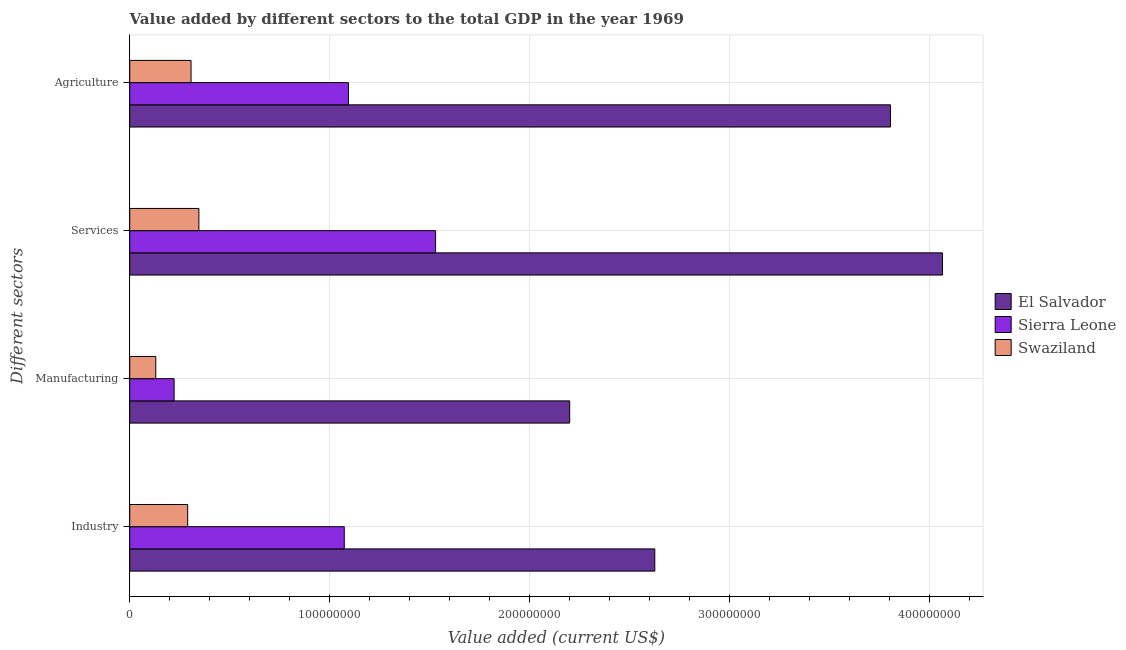How many different coloured bars are there?
Offer a terse response. 3. Are the number of bars per tick equal to the number of legend labels?
Provide a succinct answer. Yes. Are the number of bars on each tick of the Y-axis equal?
Provide a succinct answer. Yes. How many bars are there on the 2nd tick from the bottom?
Make the answer very short. 3. What is the label of the 4th group of bars from the top?
Keep it short and to the point. Industry. What is the value added by agricultural sector in Swaziland?
Make the answer very short. 3.07e+07. Across all countries, what is the maximum value added by industrial sector?
Give a very brief answer. 2.63e+08. Across all countries, what is the minimum value added by manufacturing sector?
Your answer should be very brief. 1.30e+07. In which country was the value added by manufacturing sector maximum?
Your answer should be very brief. El Salvador. In which country was the value added by agricultural sector minimum?
Offer a very short reply. Swaziland. What is the total value added by services sector in the graph?
Keep it short and to the point. 5.94e+08. What is the difference between the value added by manufacturing sector in Swaziland and that in Sierra Leone?
Your response must be concise. -9.18e+06. What is the difference between the value added by industrial sector in Swaziland and the value added by manufacturing sector in Sierra Leone?
Make the answer very short. 6.78e+06. What is the average value added by services sector per country?
Your answer should be compact. 1.98e+08. What is the difference between the value added by agricultural sector and value added by manufacturing sector in El Salvador?
Your response must be concise. 1.60e+08. In how many countries, is the value added by industrial sector greater than 40000000 US$?
Provide a short and direct response. 2. What is the ratio of the value added by industrial sector in El Salvador to that in Sierra Leone?
Provide a short and direct response. 2.45. What is the difference between the highest and the second highest value added by manufacturing sector?
Your response must be concise. 1.98e+08. What is the difference between the highest and the lowest value added by services sector?
Your answer should be very brief. 3.72e+08. What does the 2nd bar from the top in Agriculture represents?
Offer a very short reply. Sierra Leone. What does the 2nd bar from the bottom in Agriculture represents?
Your response must be concise. Sierra Leone. Is it the case that in every country, the sum of the value added by industrial sector and value added by manufacturing sector is greater than the value added by services sector?
Keep it short and to the point. No. How many bars are there?
Provide a succinct answer. 12. Are all the bars in the graph horizontal?
Offer a terse response. Yes. Are the values on the major ticks of X-axis written in scientific E-notation?
Ensure brevity in your answer.  No. Does the graph contain any zero values?
Ensure brevity in your answer.  No. Does the graph contain grids?
Your response must be concise. Yes. How are the legend labels stacked?
Keep it short and to the point. Vertical. What is the title of the graph?
Give a very brief answer. Value added by different sectors to the total GDP in the year 1969. What is the label or title of the X-axis?
Offer a terse response. Value added (current US$). What is the label or title of the Y-axis?
Give a very brief answer. Different sectors. What is the Value added (current US$) of El Salvador in Industry?
Provide a succinct answer. 2.63e+08. What is the Value added (current US$) of Sierra Leone in Industry?
Provide a short and direct response. 1.07e+08. What is the Value added (current US$) in Swaziland in Industry?
Make the answer very short. 2.90e+07. What is the Value added (current US$) of El Salvador in Manufacturing?
Provide a succinct answer. 2.20e+08. What is the Value added (current US$) of Sierra Leone in Manufacturing?
Your answer should be very brief. 2.22e+07. What is the Value added (current US$) in Swaziland in Manufacturing?
Ensure brevity in your answer.  1.30e+07. What is the Value added (current US$) of El Salvador in Services?
Ensure brevity in your answer.  4.06e+08. What is the Value added (current US$) of Sierra Leone in Services?
Your answer should be compact. 1.53e+08. What is the Value added (current US$) in Swaziland in Services?
Your response must be concise. 3.46e+07. What is the Value added (current US$) in El Salvador in Agriculture?
Offer a very short reply. 3.80e+08. What is the Value added (current US$) in Sierra Leone in Agriculture?
Provide a succinct answer. 1.09e+08. What is the Value added (current US$) of Swaziland in Agriculture?
Your answer should be compact. 3.07e+07. Across all Different sectors, what is the maximum Value added (current US$) of El Salvador?
Ensure brevity in your answer.  4.06e+08. Across all Different sectors, what is the maximum Value added (current US$) of Sierra Leone?
Your response must be concise. 1.53e+08. Across all Different sectors, what is the maximum Value added (current US$) of Swaziland?
Keep it short and to the point. 3.46e+07. Across all Different sectors, what is the minimum Value added (current US$) in El Salvador?
Provide a succinct answer. 2.20e+08. Across all Different sectors, what is the minimum Value added (current US$) in Sierra Leone?
Make the answer very short. 2.22e+07. Across all Different sectors, what is the minimum Value added (current US$) in Swaziland?
Provide a short and direct response. 1.30e+07. What is the total Value added (current US$) in El Salvador in the graph?
Your answer should be very brief. 1.27e+09. What is the total Value added (current US$) of Sierra Leone in the graph?
Your response must be concise. 3.92e+08. What is the total Value added (current US$) in Swaziland in the graph?
Ensure brevity in your answer.  1.07e+08. What is the difference between the Value added (current US$) of El Salvador in Industry and that in Manufacturing?
Offer a terse response. 4.26e+07. What is the difference between the Value added (current US$) in Sierra Leone in Industry and that in Manufacturing?
Give a very brief answer. 8.51e+07. What is the difference between the Value added (current US$) in Swaziland in Industry and that in Manufacturing?
Give a very brief answer. 1.60e+07. What is the difference between the Value added (current US$) of El Salvador in Industry and that in Services?
Make the answer very short. -1.44e+08. What is the difference between the Value added (current US$) of Sierra Leone in Industry and that in Services?
Offer a very short reply. -4.57e+07. What is the difference between the Value added (current US$) in Swaziland in Industry and that in Services?
Your answer should be very brief. -5.60e+06. What is the difference between the Value added (current US$) in El Salvador in Industry and that in Agriculture?
Your answer should be very brief. -1.18e+08. What is the difference between the Value added (current US$) of Sierra Leone in Industry and that in Agriculture?
Your answer should be very brief. -2.10e+06. What is the difference between the Value added (current US$) in Swaziland in Industry and that in Agriculture?
Keep it short and to the point. -1.68e+06. What is the difference between the Value added (current US$) of El Salvador in Manufacturing and that in Services?
Give a very brief answer. -1.86e+08. What is the difference between the Value added (current US$) of Sierra Leone in Manufacturing and that in Services?
Offer a terse response. -1.31e+08. What is the difference between the Value added (current US$) in Swaziland in Manufacturing and that in Services?
Make the answer very short. -2.16e+07. What is the difference between the Value added (current US$) in El Salvador in Manufacturing and that in Agriculture?
Make the answer very short. -1.60e+08. What is the difference between the Value added (current US$) of Sierra Leone in Manufacturing and that in Agriculture?
Provide a succinct answer. -8.72e+07. What is the difference between the Value added (current US$) of Swaziland in Manufacturing and that in Agriculture?
Make the answer very short. -1.76e+07. What is the difference between the Value added (current US$) of El Salvador in Services and that in Agriculture?
Make the answer very short. 2.60e+07. What is the difference between the Value added (current US$) in Sierra Leone in Services and that in Agriculture?
Make the answer very short. 4.36e+07. What is the difference between the Value added (current US$) in Swaziland in Services and that in Agriculture?
Offer a terse response. 3.92e+06. What is the difference between the Value added (current US$) of El Salvador in Industry and the Value added (current US$) of Sierra Leone in Manufacturing?
Make the answer very short. 2.40e+08. What is the difference between the Value added (current US$) in El Salvador in Industry and the Value added (current US$) in Swaziland in Manufacturing?
Provide a short and direct response. 2.50e+08. What is the difference between the Value added (current US$) in Sierra Leone in Industry and the Value added (current US$) in Swaziland in Manufacturing?
Your response must be concise. 9.43e+07. What is the difference between the Value added (current US$) in El Salvador in Industry and the Value added (current US$) in Sierra Leone in Services?
Ensure brevity in your answer.  1.10e+08. What is the difference between the Value added (current US$) of El Salvador in Industry and the Value added (current US$) of Swaziland in Services?
Offer a terse response. 2.28e+08. What is the difference between the Value added (current US$) in Sierra Leone in Industry and the Value added (current US$) in Swaziland in Services?
Your response must be concise. 7.27e+07. What is the difference between the Value added (current US$) of El Salvador in Industry and the Value added (current US$) of Sierra Leone in Agriculture?
Make the answer very short. 1.53e+08. What is the difference between the Value added (current US$) in El Salvador in Industry and the Value added (current US$) in Swaziland in Agriculture?
Make the answer very short. 2.32e+08. What is the difference between the Value added (current US$) in Sierra Leone in Industry and the Value added (current US$) in Swaziland in Agriculture?
Offer a very short reply. 7.66e+07. What is the difference between the Value added (current US$) in El Salvador in Manufacturing and the Value added (current US$) in Sierra Leone in Services?
Your answer should be very brief. 6.71e+07. What is the difference between the Value added (current US$) of El Salvador in Manufacturing and the Value added (current US$) of Swaziland in Services?
Offer a very short reply. 1.85e+08. What is the difference between the Value added (current US$) of Sierra Leone in Manufacturing and the Value added (current US$) of Swaziland in Services?
Make the answer very short. -1.24e+07. What is the difference between the Value added (current US$) of El Salvador in Manufacturing and the Value added (current US$) of Sierra Leone in Agriculture?
Your answer should be compact. 1.11e+08. What is the difference between the Value added (current US$) in El Salvador in Manufacturing and the Value added (current US$) in Swaziland in Agriculture?
Your answer should be very brief. 1.89e+08. What is the difference between the Value added (current US$) in Sierra Leone in Manufacturing and the Value added (current US$) in Swaziland in Agriculture?
Provide a short and direct response. -8.46e+06. What is the difference between the Value added (current US$) of El Salvador in Services and the Value added (current US$) of Sierra Leone in Agriculture?
Keep it short and to the point. 2.97e+08. What is the difference between the Value added (current US$) of El Salvador in Services and the Value added (current US$) of Swaziland in Agriculture?
Make the answer very short. 3.76e+08. What is the difference between the Value added (current US$) of Sierra Leone in Services and the Value added (current US$) of Swaziland in Agriculture?
Provide a succinct answer. 1.22e+08. What is the average Value added (current US$) of El Salvador per Different sectors?
Your answer should be very brief. 3.17e+08. What is the average Value added (current US$) of Sierra Leone per Different sectors?
Your response must be concise. 9.80e+07. What is the average Value added (current US$) of Swaziland per Different sectors?
Make the answer very short. 2.68e+07. What is the difference between the Value added (current US$) of El Salvador and Value added (current US$) of Sierra Leone in Industry?
Make the answer very short. 1.55e+08. What is the difference between the Value added (current US$) of El Salvador and Value added (current US$) of Swaziland in Industry?
Keep it short and to the point. 2.34e+08. What is the difference between the Value added (current US$) in Sierra Leone and Value added (current US$) in Swaziland in Industry?
Offer a very short reply. 7.83e+07. What is the difference between the Value added (current US$) in El Salvador and Value added (current US$) in Sierra Leone in Manufacturing?
Offer a terse response. 1.98e+08. What is the difference between the Value added (current US$) in El Salvador and Value added (current US$) in Swaziland in Manufacturing?
Your response must be concise. 2.07e+08. What is the difference between the Value added (current US$) in Sierra Leone and Value added (current US$) in Swaziland in Manufacturing?
Offer a very short reply. 9.18e+06. What is the difference between the Value added (current US$) in El Salvador and Value added (current US$) in Sierra Leone in Services?
Your answer should be very brief. 2.53e+08. What is the difference between the Value added (current US$) of El Salvador and Value added (current US$) of Swaziland in Services?
Ensure brevity in your answer.  3.72e+08. What is the difference between the Value added (current US$) in Sierra Leone and Value added (current US$) in Swaziland in Services?
Your answer should be compact. 1.18e+08. What is the difference between the Value added (current US$) of El Salvador and Value added (current US$) of Sierra Leone in Agriculture?
Your answer should be very brief. 2.71e+08. What is the difference between the Value added (current US$) of El Salvador and Value added (current US$) of Swaziland in Agriculture?
Provide a succinct answer. 3.50e+08. What is the difference between the Value added (current US$) of Sierra Leone and Value added (current US$) of Swaziland in Agriculture?
Provide a succinct answer. 7.87e+07. What is the ratio of the Value added (current US$) in El Salvador in Industry to that in Manufacturing?
Your answer should be compact. 1.19. What is the ratio of the Value added (current US$) of Sierra Leone in Industry to that in Manufacturing?
Make the answer very short. 4.83. What is the ratio of the Value added (current US$) of Swaziland in Industry to that in Manufacturing?
Your answer should be very brief. 2.23. What is the ratio of the Value added (current US$) of El Salvador in Industry to that in Services?
Offer a terse response. 0.65. What is the ratio of the Value added (current US$) of Sierra Leone in Industry to that in Services?
Give a very brief answer. 0.7. What is the ratio of the Value added (current US$) in Swaziland in Industry to that in Services?
Ensure brevity in your answer.  0.84. What is the ratio of the Value added (current US$) in El Salvador in Industry to that in Agriculture?
Provide a short and direct response. 0.69. What is the ratio of the Value added (current US$) in Sierra Leone in Industry to that in Agriculture?
Ensure brevity in your answer.  0.98. What is the ratio of the Value added (current US$) of Swaziland in Industry to that in Agriculture?
Keep it short and to the point. 0.95. What is the ratio of the Value added (current US$) of El Salvador in Manufacturing to that in Services?
Your response must be concise. 0.54. What is the ratio of the Value added (current US$) of Sierra Leone in Manufacturing to that in Services?
Your answer should be very brief. 0.15. What is the ratio of the Value added (current US$) in Swaziland in Manufacturing to that in Services?
Provide a succinct answer. 0.38. What is the ratio of the Value added (current US$) of El Salvador in Manufacturing to that in Agriculture?
Your response must be concise. 0.58. What is the ratio of the Value added (current US$) of Sierra Leone in Manufacturing to that in Agriculture?
Offer a terse response. 0.2. What is the ratio of the Value added (current US$) in Swaziland in Manufacturing to that in Agriculture?
Your answer should be very brief. 0.42. What is the ratio of the Value added (current US$) in El Salvador in Services to that in Agriculture?
Offer a very short reply. 1.07. What is the ratio of the Value added (current US$) in Sierra Leone in Services to that in Agriculture?
Provide a succinct answer. 1.4. What is the ratio of the Value added (current US$) in Swaziland in Services to that in Agriculture?
Provide a succinct answer. 1.13. What is the difference between the highest and the second highest Value added (current US$) of El Salvador?
Ensure brevity in your answer.  2.60e+07. What is the difference between the highest and the second highest Value added (current US$) of Sierra Leone?
Provide a short and direct response. 4.36e+07. What is the difference between the highest and the second highest Value added (current US$) of Swaziland?
Keep it short and to the point. 3.92e+06. What is the difference between the highest and the lowest Value added (current US$) of El Salvador?
Offer a terse response. 1.86e+08. What is the difference between the highest and the lowest Value added (current US$) of Sierra Leone?
Offer a terse response. 1.31e+08. What is the difference between the highest and the lowest Value added (current US$) in Swaziland?
Offer a very short reply. 2.16e+07. 